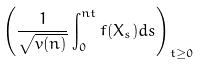<formula> <loc_0><loc_0><loc_500><loc_500>\left ( \frac { 1 } { \sqrt { v ( n ) } } \int _ { 0 } ^ { n t } f ( X _ { s } ) d s \right ) _ { t \geq 0 }</formula> 